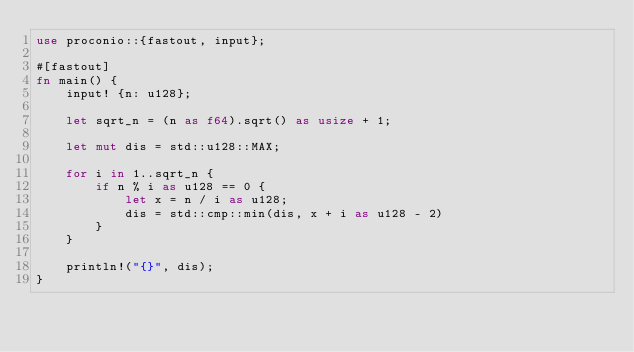Convert code to text. <code><loc_0><loc_0><loc_500><loc_500><_Rust_>use proconio::{fastout, input};

#[fastout]
fn main() {
    input! {n: u128};

    let sqrt_n = (n as f64).sqrt() as usize + 1;

    let mut dis = std::u128::MAX;

    for i in 1..sqrt_n {
        if n % i as u128 == 0 {
            let x = n / i as u128;
            dis = std::cmp::min(dis, x + i as u128 - 2)
        }
    }

    println!("{}", dis);
}
</code> 